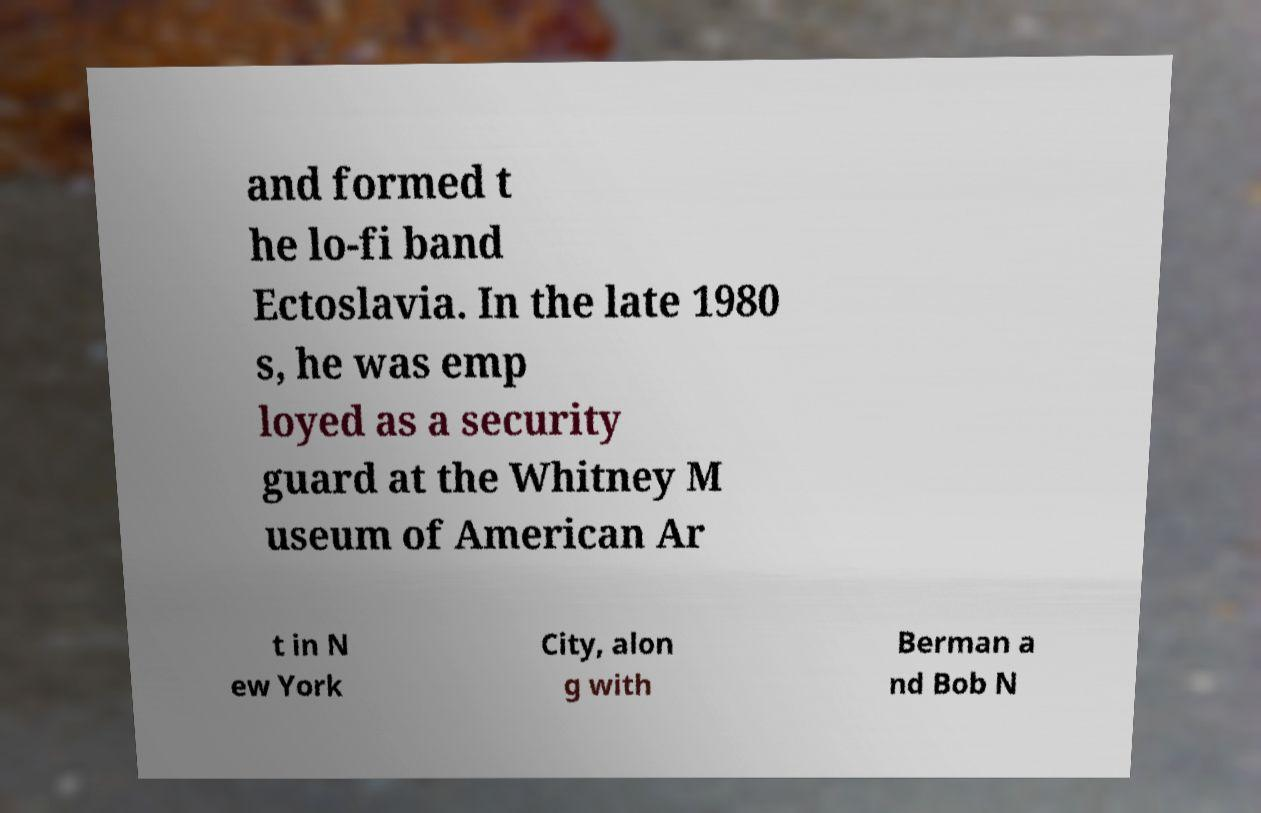For documentation purposes, I need the text within this image transcribed. Could you provide that? and formed t he lo-fi band Ectoslavia. In the late 1980 s, he was emp loyed as a security guard at the Whitney M useum of American Ar t in N ew York City, alon g with Berman a nd Bob N 